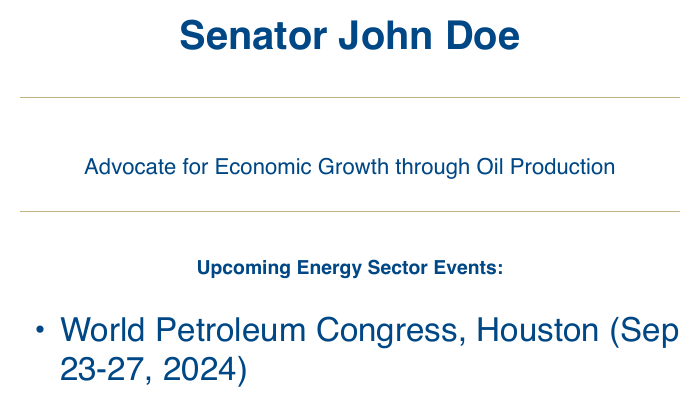What is the name of the senator? The senator's name is mentioned at the top of the card, identifying him as the author of the document.
Answer: Senator John Doe What is the main focus of the senator? The senator's advocacy is highlighted in the subtitle, indicating his stance clearly.
Answer: Advocate for Economic Growth through Oil Production When is the World Petroleum Congress scheduled? The specific date for this event is provided in the list of upcoming events within the document.
Answer: Sep 23-27, 2024 Where is the OPEC International Seminar taking place? The location of this seminar is stated in the document within the event list.
Answer: Vienna How many events are listed on the card? The total number of events can be determined by counting the items under the upcoming events section.
Answer: 3 What is the date range for the North American Petroleum Expo? The date range for this specific conference is specified among the upcoming events in the document.
Answer: May 5-7, 2024 What is the contact phone number for the senator? The phone number is listed at the bottom section of the document, providing contact information.
Answer: (555) 123-4567 What color is used for the senator's name on the card? The color used for the senator's name is specified in the document, depicting it prominently.
Answer: Oil blue 